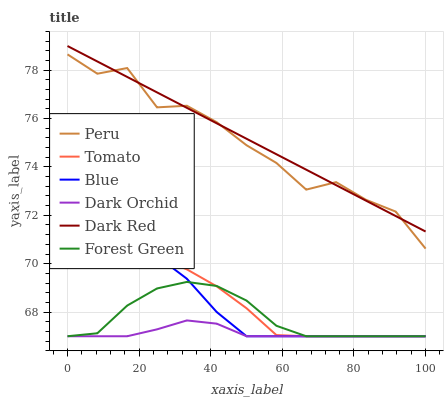Does Blue have the minimum area under the curve?
Answer yes or no. No. Does Blue have the maximum area under the curve?
Answer yes or no. No. Is Blue the smoothest?
Answer yes or no. No. Is Blue the roughest?
Answer yes or no. No. Does Dark Red have the lowest value?
Answer yes or no. No. Does Blue have the highest value?
Answer yes or no. No. Is Tomato less than Dark Red?
Answer yes or no. Yes. Is Peru greater than Blue?
Answer yes or no. Yes. Does Tomato intersect Dark Red?
Answer yes or no. No. 